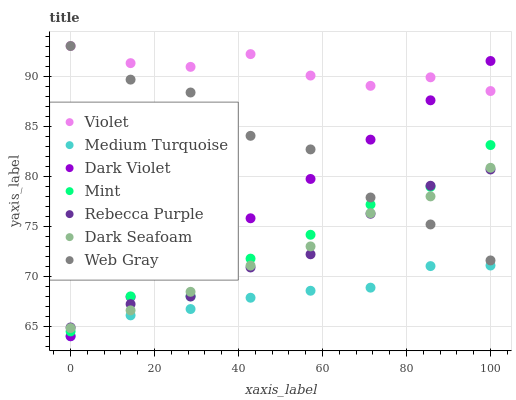Does Medium Turquoise have the minimum area under the curve?
Answer yes or no. Yes. Does Violet have the maximum area under the curve?
Answer yes or no. Yes. Does Dark Violet have the minimum area under the curve?
Answer yes or no. No. Does Dark Violet have the maximum area under the curve?
Answer yes or no. No. Is Dark Violet the smoothest?
Answer yes or no. Yes. Is Web Gray the roughest?
Answer yes or no. Yes. Is Dark Seafoam the smoothest?
Answer yes or no. No. Is Dark Seafoam the roughest?
Answer yes or no. No. Does Dark Violet have the lowest value?
Answer yes or no. Yes. Does Dark Seafoam have the lowest value?
Answer yes or no. No. Does Violet have the highest value?
Answer yes or no. Yes. Does Dark Violet have the highest value?
Answer yes or no. No. Is Medium Turquoise less than Violet?
Answer yes or no. Yes. Is Web Gray greater than Medium Turquoise?
Answer yes or no. Yes. Does Dark Violet intersect Mint?
Answer yes or no. Yes. Is Dark Violet less than Mint?
Answer yes or no. No. Is Dark Violet greater than Mint?
Answer yes or no. No. Does Medium Turquoise intersect Violet?
Answer yes or no. No. 